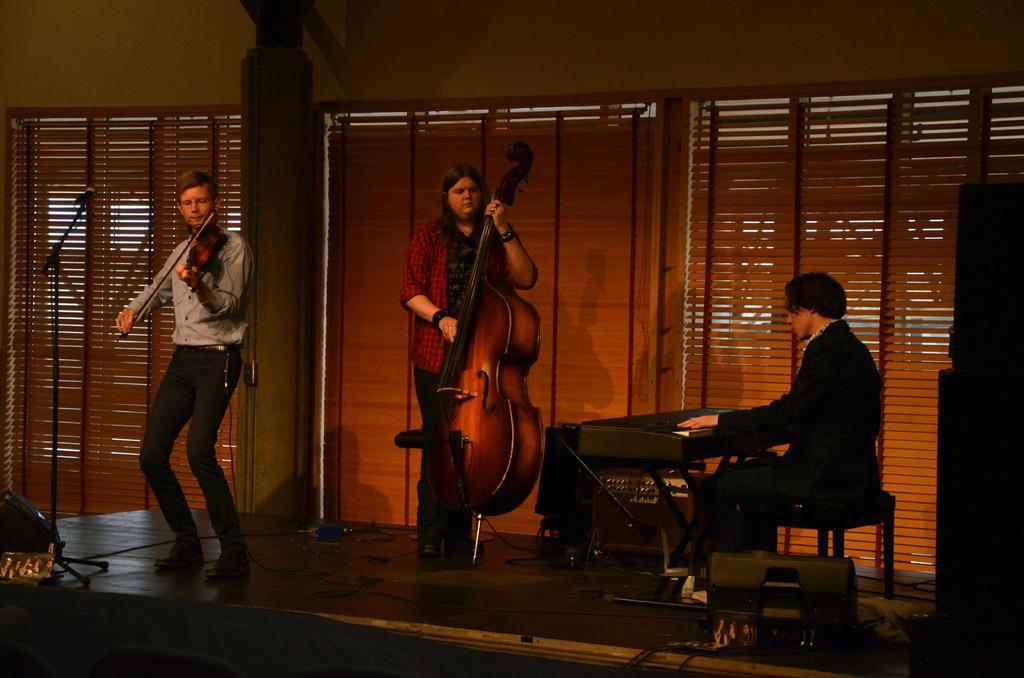How would you summarize this image in a sentence or two? In the image we can see three persons. In the center the woman she is holding guitar. On the left we can see man holding violin. On the right we can see man sitting and in front of them we can see microphone. And coming to the background we can see wall. 